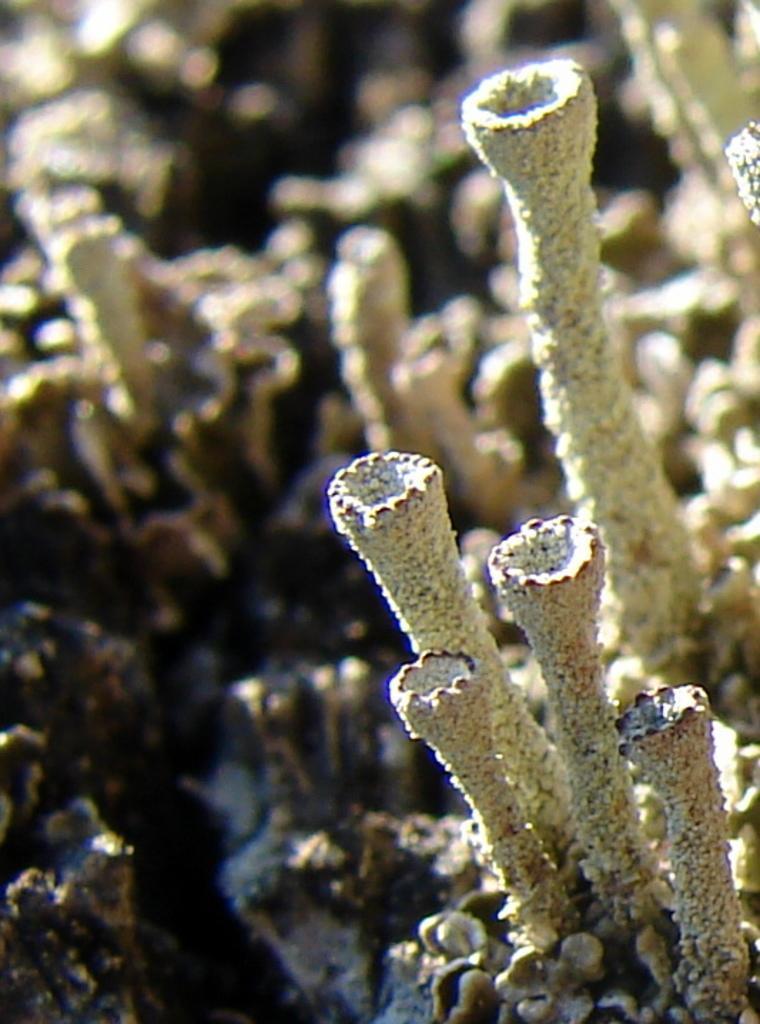Can you describe this image briefly? In this picture there is a marine plant. 